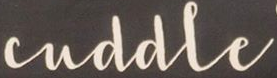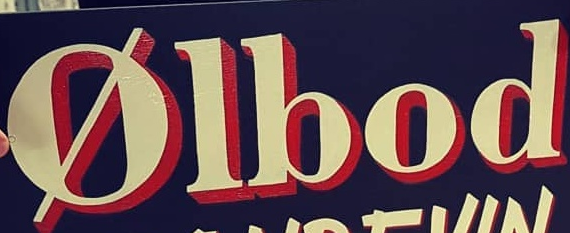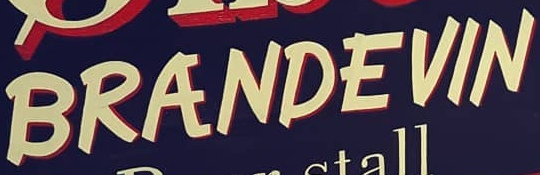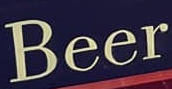Read the text content from these images in order, separated by a semicolon. cuddle; Ølbod; BRANDEVIN; Beer 